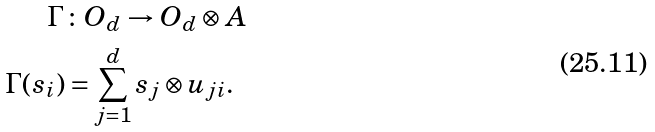<formula> <loc_0><loc_0><loc_500><loc_500>\Gamma & \colon O _ { d } \to O _ { d } \otimes A \\ \Gamma ( s _ { i } ) & = \sum _ { j = 1 } ^ { d } s _ { j } \otimes u _ { j i } .</formula> 